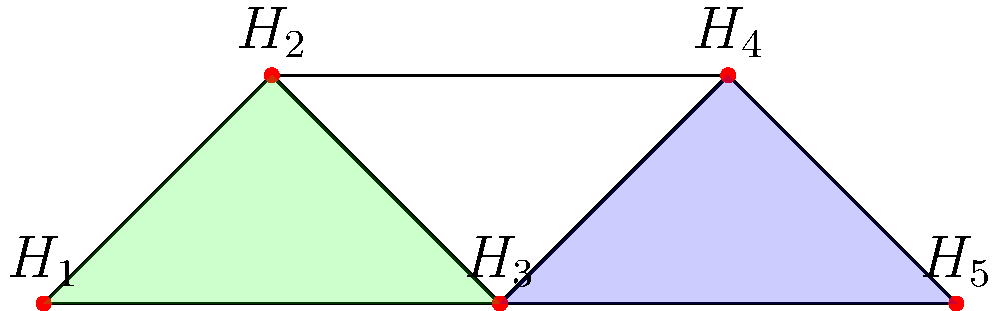In the graph above, each vertex represents a protected habitat (H1 to H5), and edges represent possible wildlife corridors between habitats. Using graph coloring techniques, what is the minimum number of colors needed to ensure that no two adjacent habitats have the same color, and what does this number signify in terms of habitat management? To solve this problem, we'll use graph coloring techniques and analyze their implications for habitat management:

1. First, we need to understand what graph coloring means in this context:
   - Each color represents a distinct management approach or resource allocation.
   - Adjacent habitats (connected by edges) should have different colors to minimize interference or competition.

2. Now, let's color the graph step by step:
   - Start with H1: Assign it Color 1.
   - H2 is adjacent to H1, so it needs a different color: Color 2.
   - H3 is adjacent to both H1 and H2, so it needs a new color: Color 3.
   - H4 is adjacent to H2 and H3, but not H1, so we can use Color 1 again.
   - H5 is adjacent to H3 and H4, so we can use Color 2.

3. Counting the colors used, we find that the minimum number is 3.

4. Interpretation for habitat management:
   - The chromatic number (minimum number of colors) represents the minimum number of distinct management approaches or resource allocations needed.
   - A lower chromatic number indicates more efficient resource use and simpler management.
   - In this case, 3 colors suggest that at least 3 different management strategies are needed to effectively manage these interconnected habitats without conflicts.

5. Implications for climate change adaptation:
   - Each color could represent a different adaptation strategy tailored to specific habitat types or climate vulnerabilities.
   - The coloring ensures that adjacent habitats with potentially different needs are managed distinctly, allowing for more targeted and effective adaptation measures.
Answer: 3 colors; minimum number of distinct management strategies needed for effective habitat management and climate adaptation. 